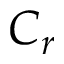<formula> <loc_0><loc_0><loc_500><loc_500>C _ { r }</formula> 